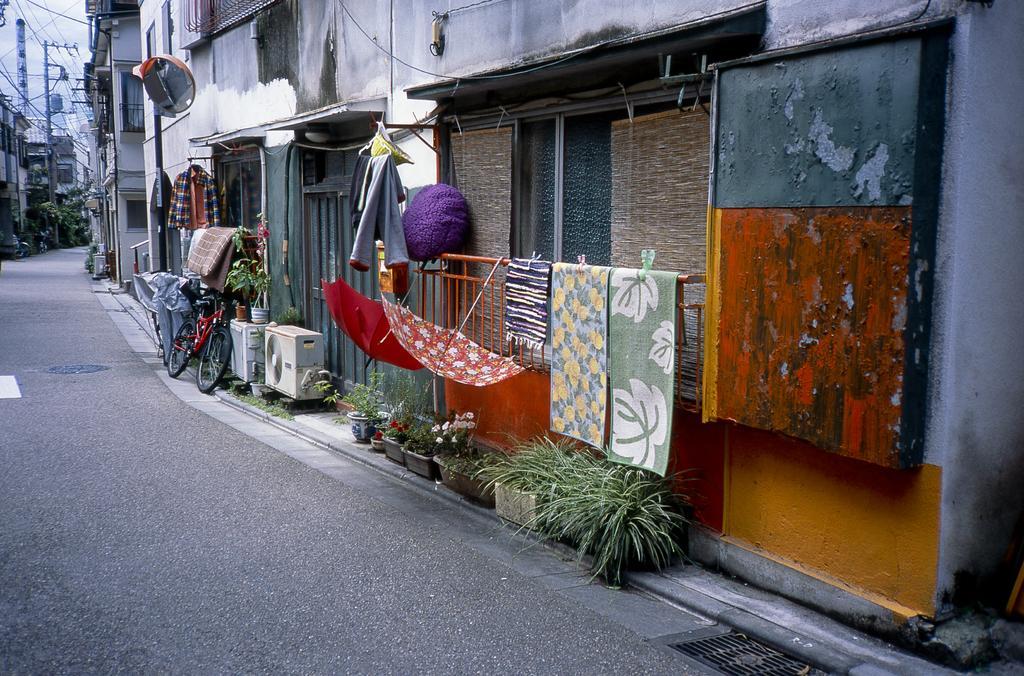How would you summarize this image in a sentence or two? In this picture we can see few buildings, poles, cables, trees, umbrellas and plants, on the left side of the image we can see a convex mirror, bicycle and air conditioner outdoor units. 